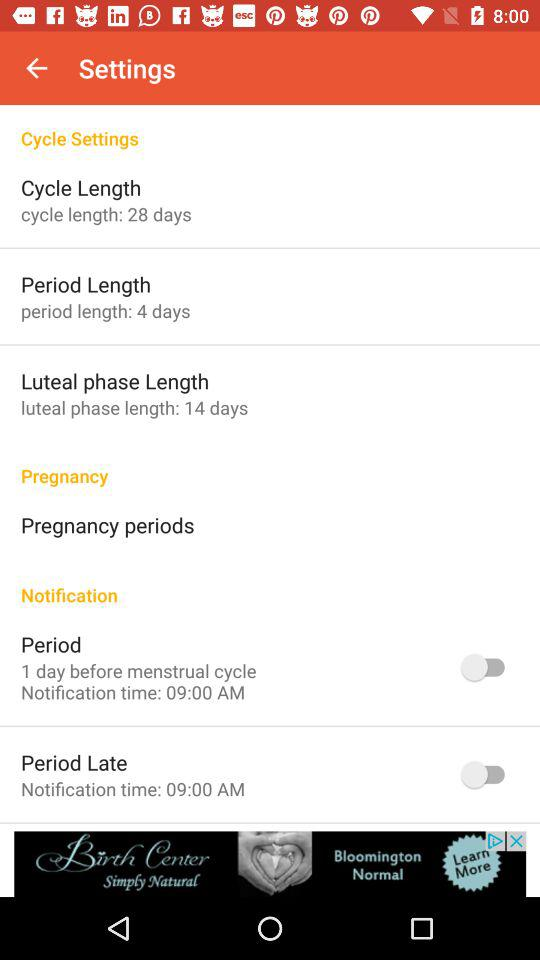What is the status of the "Period"? The status is "off". 